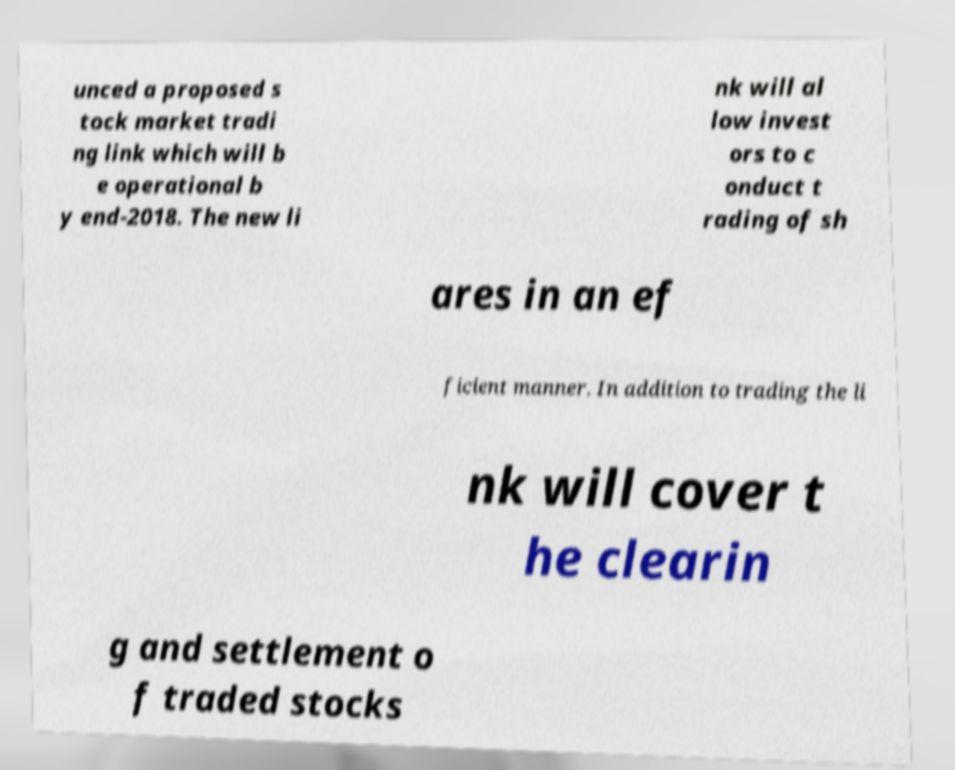Please read and relay the text visible in this image. What does it say? unced a proposed s tock market tradi ng link which will b e operational b y end-2018. The new li nk will al low invest ors to c onduct t rading of sh ares in an ef ficient manner. In addition to trading the li nk will cover t he clearin g and settlement o f traded stocks 